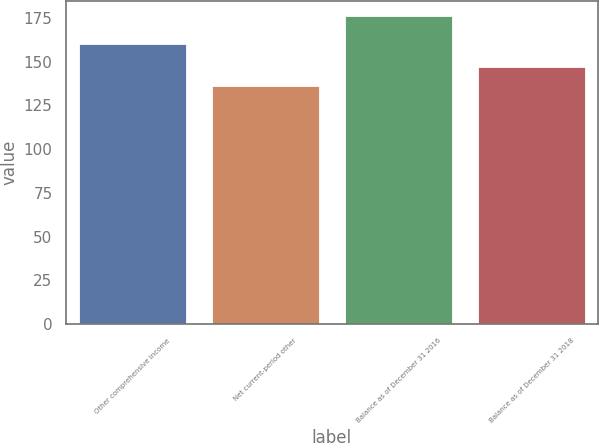<chart> <loc_0><loc_0><loc_500><loc_500><bar_chart><fcel>Other comprehensive income<fcel>Net current-period other<fcel>Balance as of December 31 2016<fcel>Balance as of December 31 2018<nl><fcel>160<fcel>136<fcel>176<fcel>147<nl></chart> 